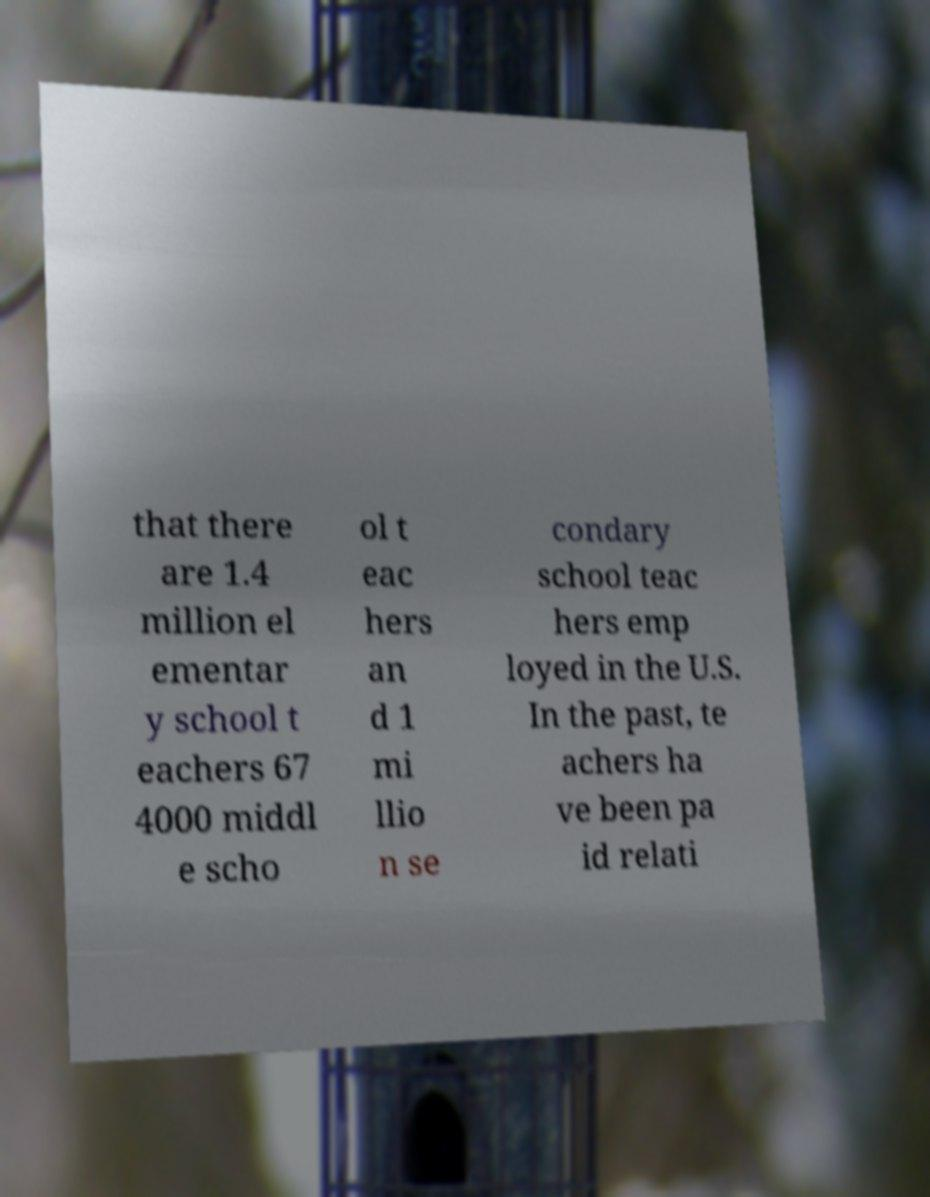For documentation purposes, I need the text within this image transcribed. Could you provide that? that there are 1.4 million el ementar y school t eachers 67 4000 middl e scho ol t eac hers an d 1 mi llio n se condary school teac hers emp loyed in the U.S. In the past, te achers ha ve been pa id relati 